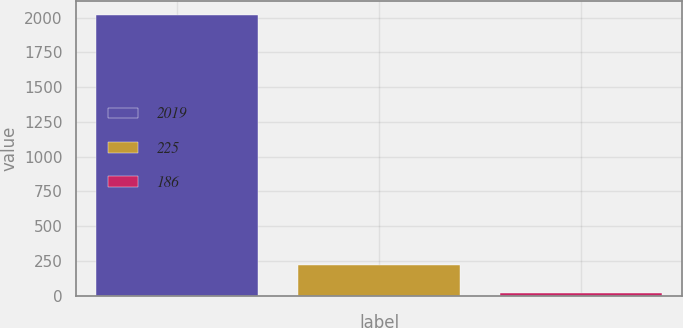<chart> <loc_0><loc_0><loc_500><loc_500><bar_chart><fcel>2019<fcel>225<fcel>186<nl><fcel>2018<fcel>219.17<fcel>19.3<nl></chart> 